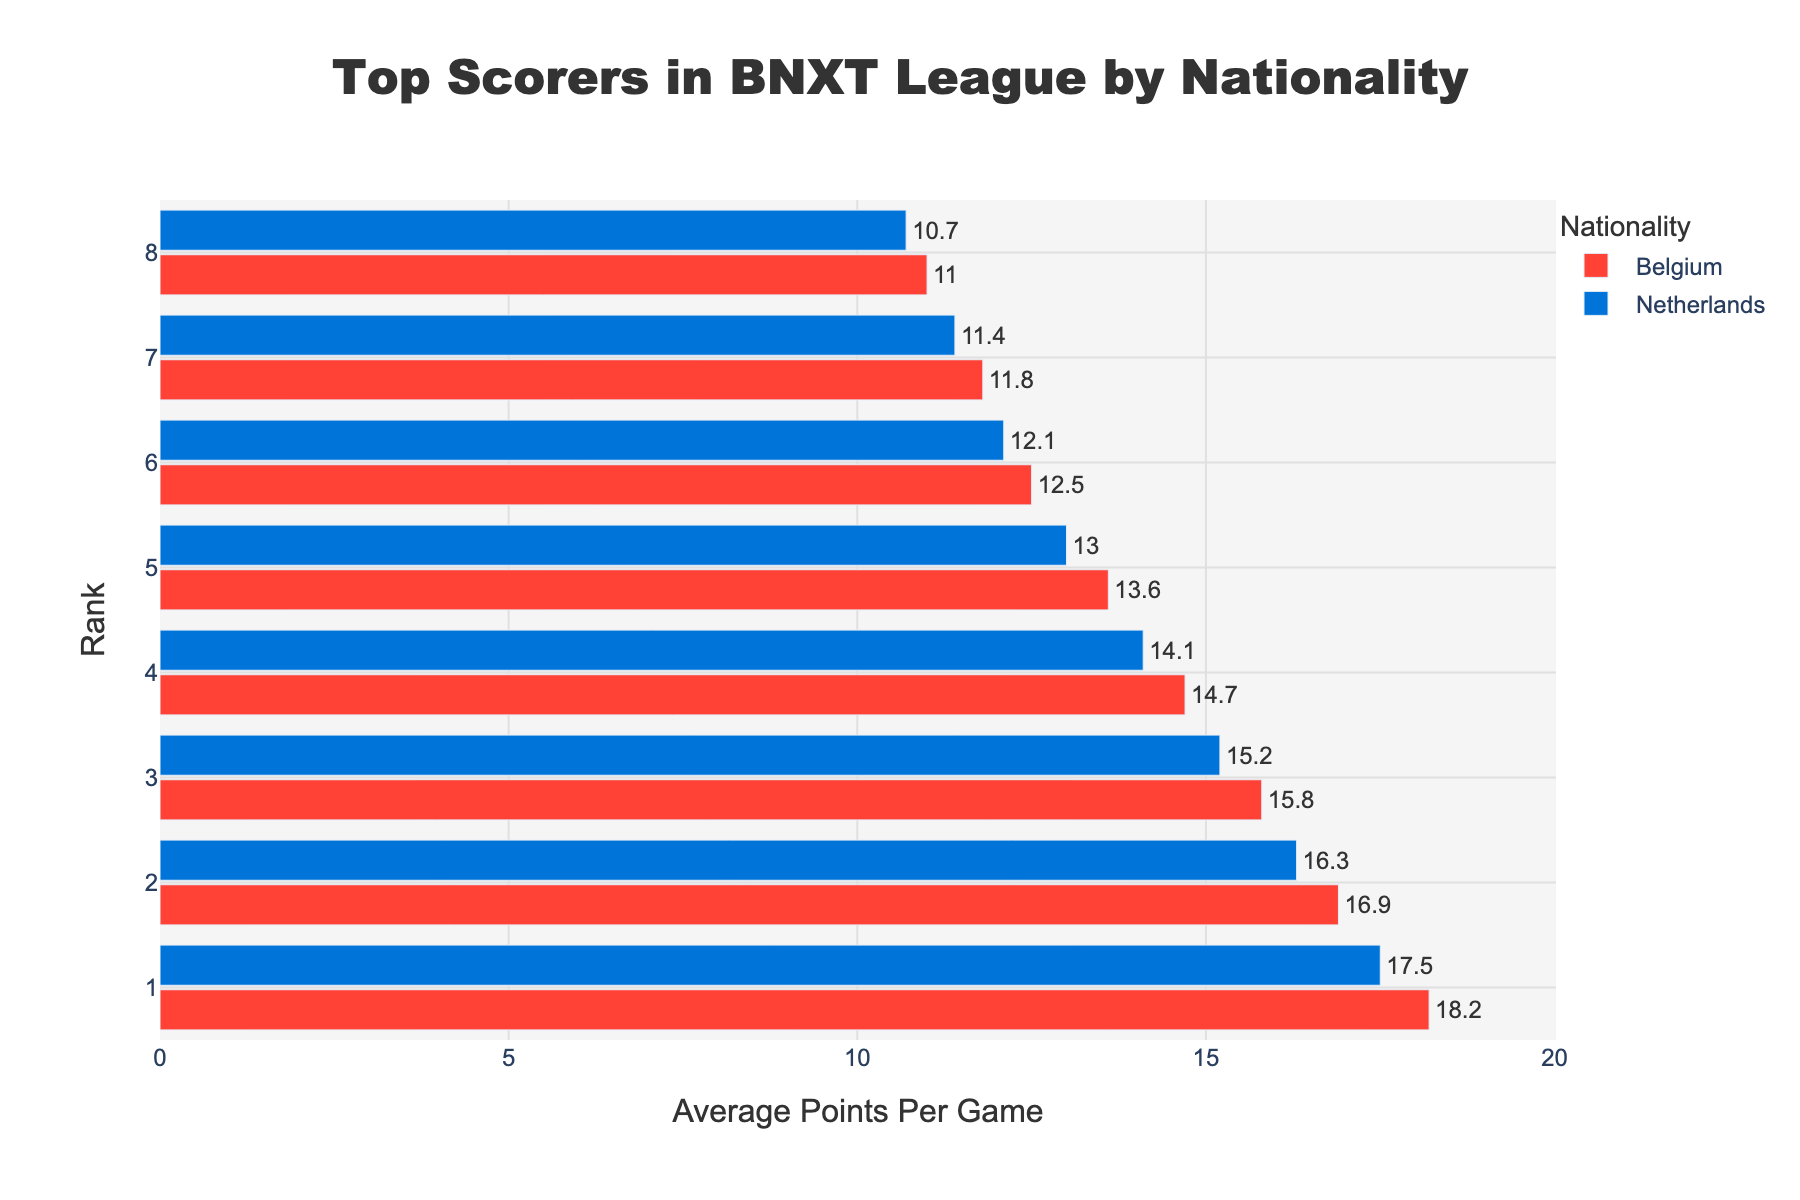What is the highest average points per game for Belgian players? The highest average points per game for Belgian players can be found by looking at the top bar labeled "Belgium" on the chart.
Answer: 18.2 Which nationality has the player with the highest average points per game and what is it? By comparing the top bars for both Belgian and Dutch players, we see that the highest average points per game overall is from Belgium at 18.2.
Answer: Belgium, 18.2 What is the difference in average points per game between the top Belgian and Dutch players? The top Belgian player averages 18.2 points, and the top Dutch player averages 17.5 points. The difference is 18.2 - 17.5.
Answer: 0.7 On average, are Belgian or Dutch players scoring more points per game in the BNXT league? The top values for each nationality show that Belgian players score 18.2 points at the highest, whereas Dutch players score 17.5 points at the highest.
Answer: Belgian players What is the total average points per game for the top 3 Belgian players? Summing up the scores of the top three Belgian players: 18.2 + 16.9 + 15.8.
Answer: 50.9 Which nationality has more players averaging above 15 points per game? Belgian players have 3 entries: 18.2, 16.9, and 15.8, whereas Dutch players have 2 entries: 17.5 and 16.3 above 15 points per game.
Answer: Belgium How many Belgian players are averaging between 10 and 15 points per game? Identifying the range-specific scores among Belgian players: 14.7, 13.6, 12.5, and 11.8 fall between 10 and 15 points per game.
Answer: 4 What is the combined average points per game for the least scoring Belgian and Dutch players? The least scoring Belgian player averages 11.0 points, and the least scoring Dutch player averages 10.7 points. Summing these up: 11.0 + 10.7.
Answer: 21.7 Compare the average points per game of Belgian players ranked 4th and Dutch players ranked 4th. The 4th rank average points for Belgian players is 14.7, while for Dutch players, it is 14.1.
Answer: Belgian players 14.7, Dutch players 14.1 